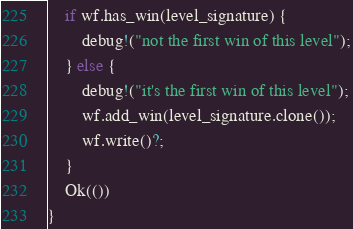<code> <loc_0><loc_0><loc_500><loc_500><_Rust_>    if wf.has_win(level_signature) {
        debug!("not the first win of this level");
    } else {
        debug!("it's the first win of this level");
        wf.add_win(level_signature.clone());
        wf.write()?;
    }
    Ok(())
}
</code> 